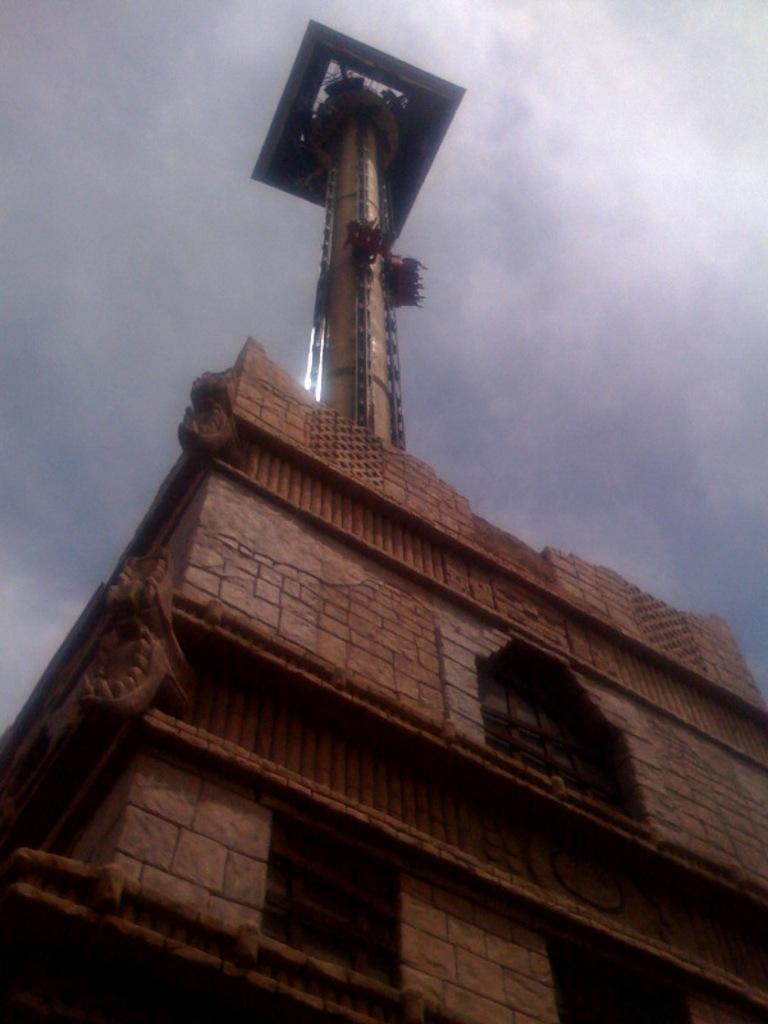Can you describe this image briefly? As we can see in the image there is a building, windows, sky and clouds. 